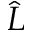<formula> <loc_0><loc_0><loc_500><loc_500>\hat { L }</formula> 